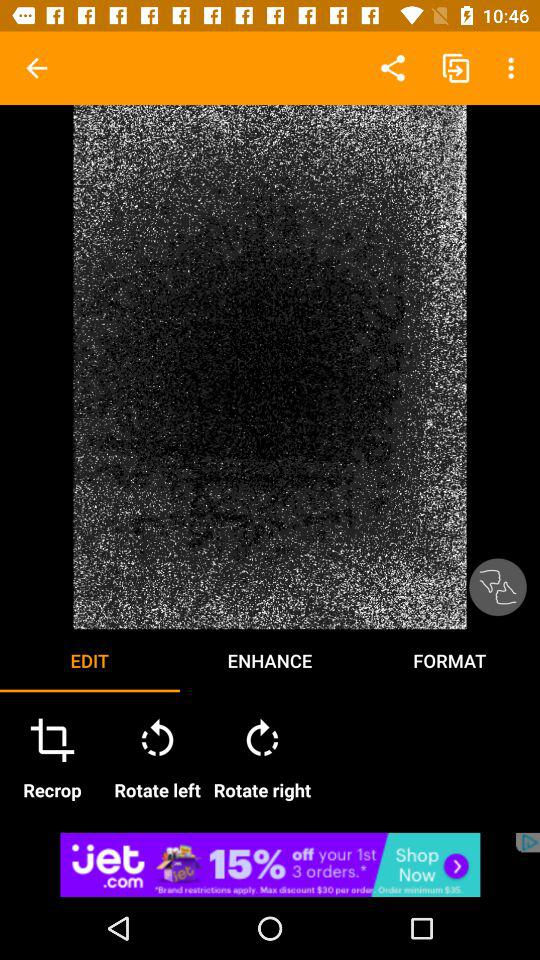What are the options in "ENHANCE"?
When the provided information is insufficient, respond with <no answer>. <no answer> 